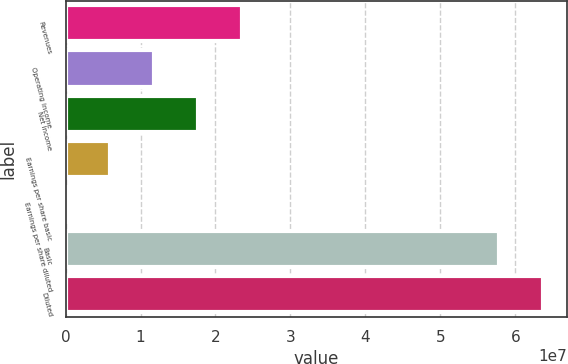<chart> <loc_0><loc_0><loc_500><loc_500><bar_chart><fcel>Revenues<fcel>Operating income<fcel>Net income<fcel>Earnings per share basic<fcel>Earnings per share diluted<fcel>Basic<fcel>Diluted<nl><fcel>2.35629e+07<fcel>1.17815e+07<fcel>1.76722e+07<fcel>5.89073e+06<fcel>0.1<fcel>5.78197e+07<fcel>6.37105e+07<nl></chart> 